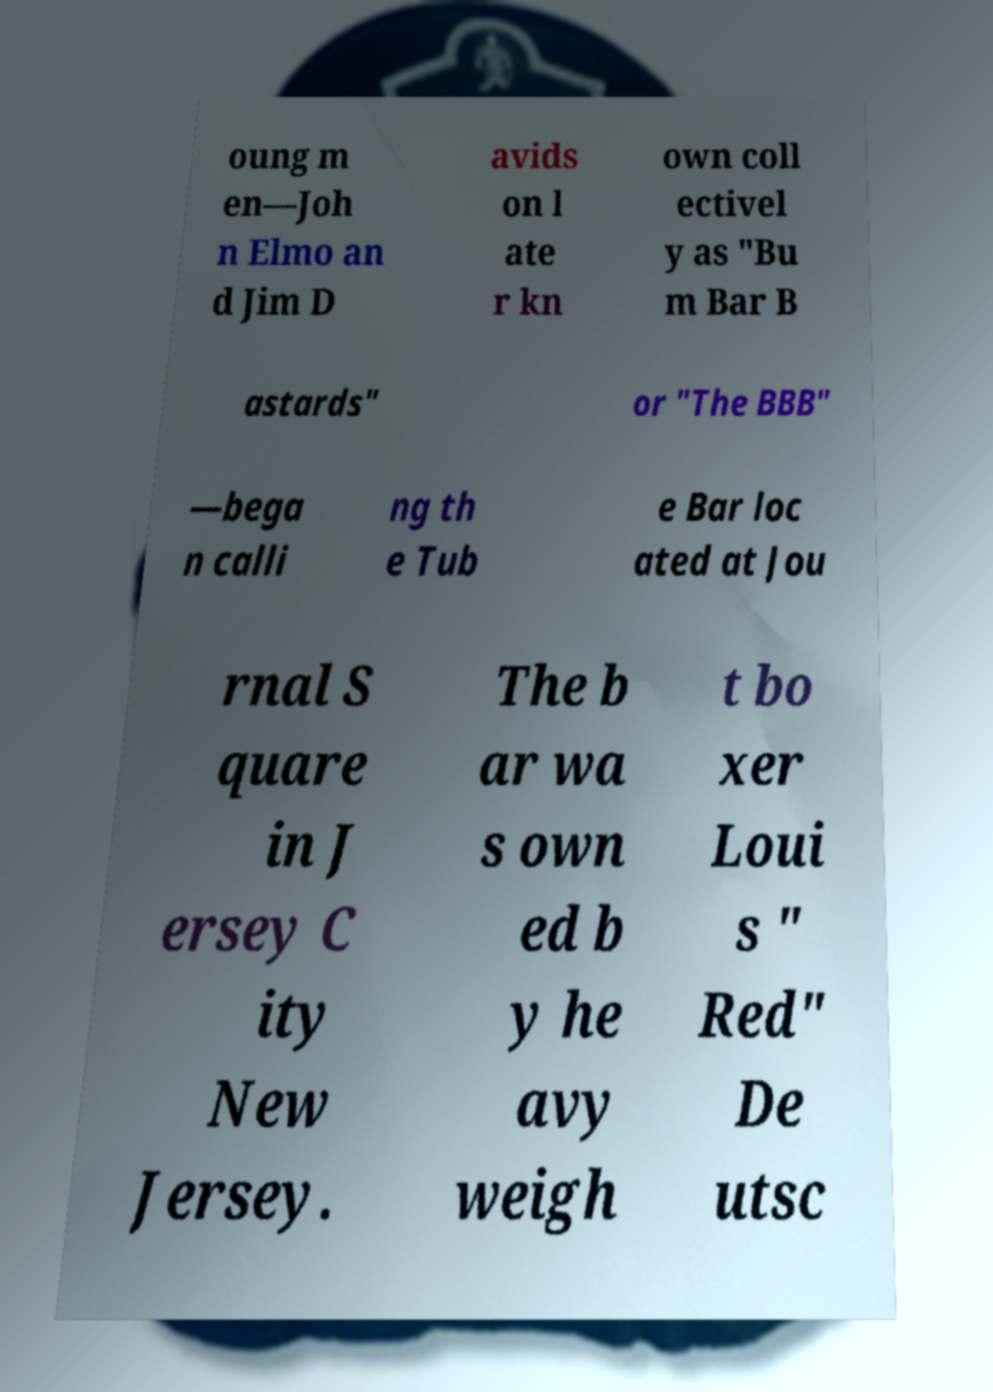For documentation purposes, I need the text within this image transcribed. Could you provide that? oung m en—Joh n Elmo an d Jim D avids on l ate r kn own coll ectivel y as "Bu m Bar B astards" or "The BBB" —bega n calli ng th e Tub e Bar loc ated at Jou rnal S quare in J ersey C ity New Jersey. The b ar wa s own ed b y he avy weigh t bo xer Loui s " Red" De utsc 